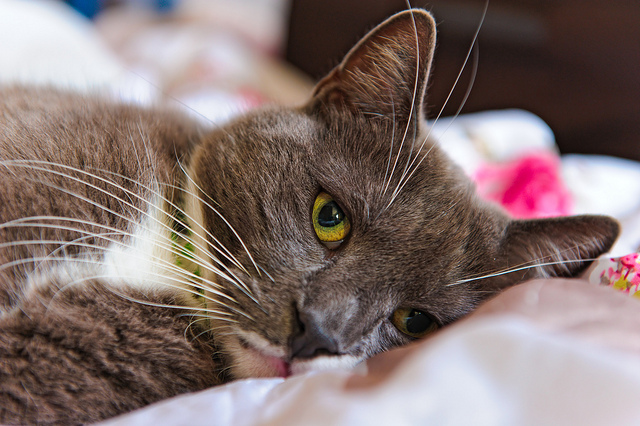Why might the cat look a little sad? The cat might appear a little sad for various reasons, which could include feelings of loneliness, boredom, or anxiety. In the image, it is lying on cozy white sheets by itself, without any human or animal companions in sight. Cats, similar to humans, experience emotions and can become unhappy if they are used to having interactions or playtime but are left alone. Additionally, the cat might be in a resting position after some physical activity, which can sometimes resemble a sad expression. Remember to provide cats with a stimulating environment and regular social interactions to keep them emotionally healthy. 